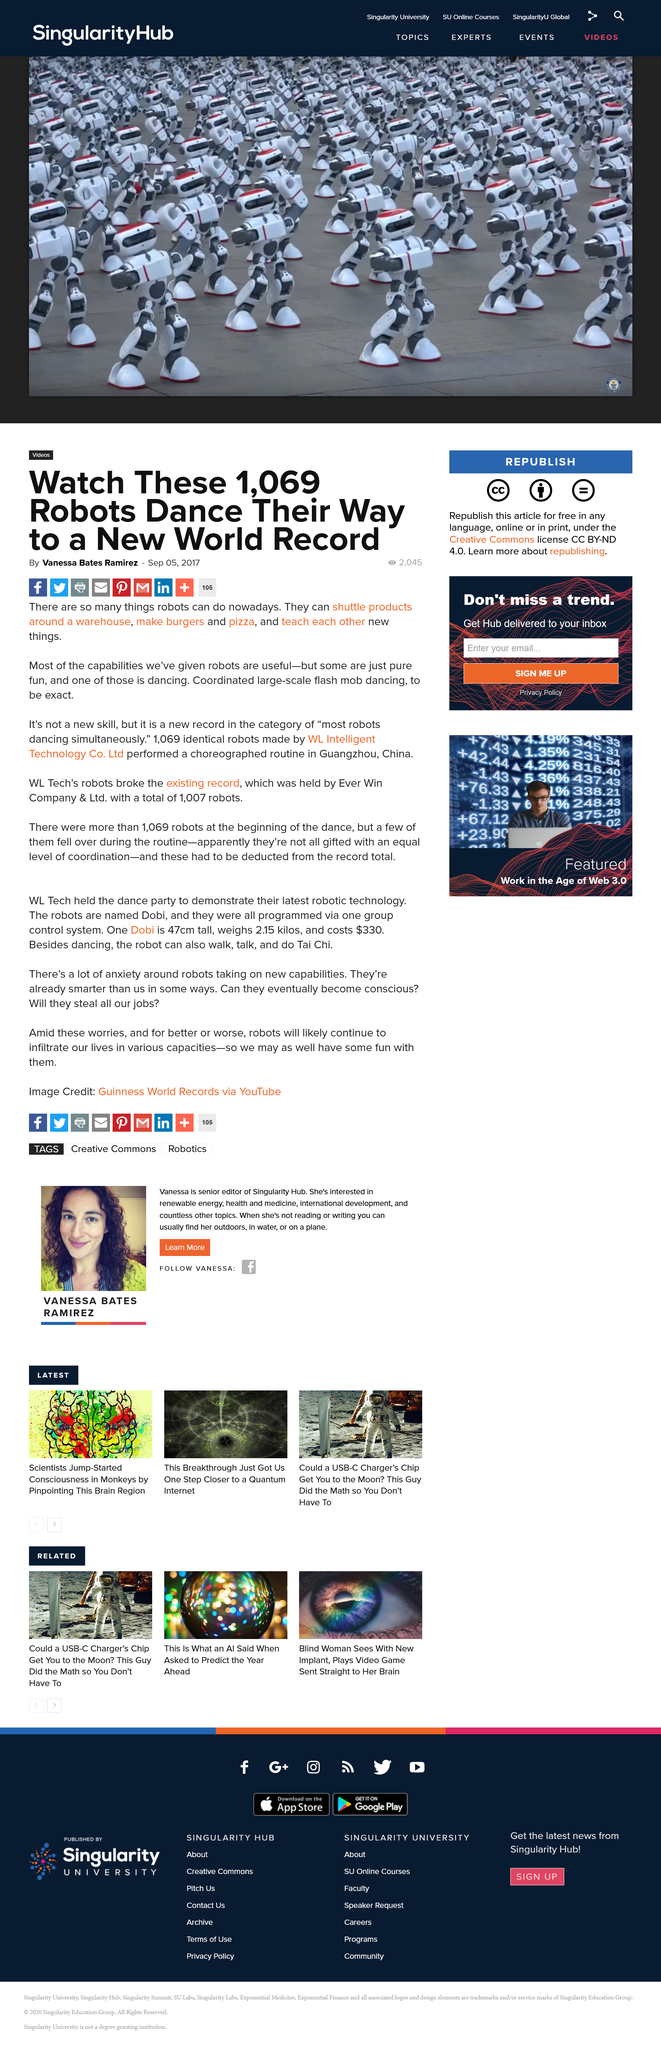Give some essential details in this illustration. The makers of these identical robots are WL Intelligent Technology Co. Ltd. Robots can perform various tasks, such as transporting products around a warehouse and preparing food. In the new record for most robots dancing simultaneously, 1069 robots participated. 